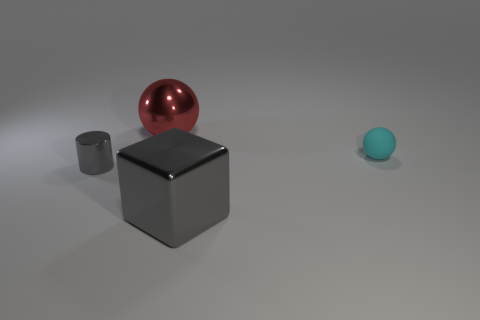There is a metal thing that is the same color as the small metal cylinder; what is its size?
Your answer should be compact. Large. Is there anything else that has the same material as the cyan sphere?
Provide a short and direct response. No. Is the material of the small object to the right of the large red shiny sphere the same as the small cylinder?
Provide a short and direct response. No. What shape is the object that is both on the right side of the tiny gray metal thing and in front of the small sphere?
Provide a succinct answer. Cube. How many large objects are either yellow cubes or matte balls?
Provide a short and direct response. 0. What is the material of the tiny ball?
Offer a terse response. Rubber. How many other objects are there of the same shape as the tiny cyan object?
Provide a succinct answer. 1. How big is the cyan object?
Your answer should be compact. Small. What size is the metal thing that is both in front of the red shiny sphere and right of the small gray metallic object?
Make the answer very short. Large. There is a shiny thing right of the red metal object; what is its shape?
Your answer should be compact. Cube. 